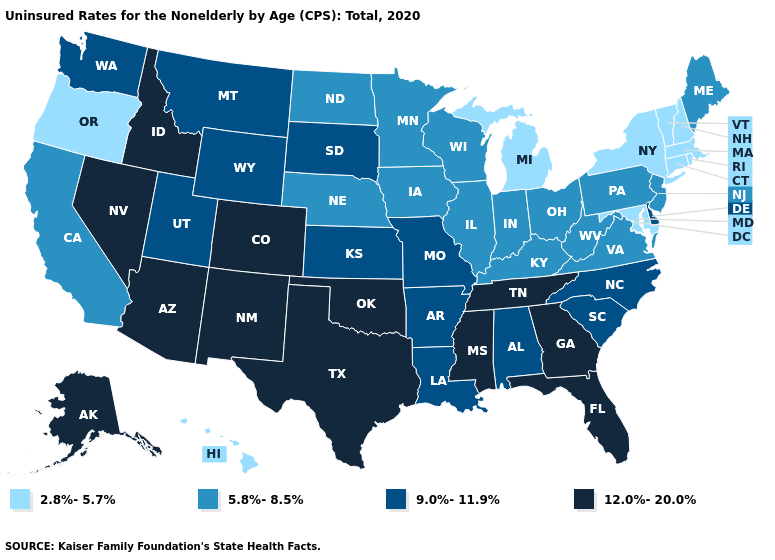Name the states that have a value in the range 2.8%-5.7%?
Concise answer only. Connecticut, Hawaii, Maryland, Massachusetts, Michigan, New Hampshire, New York, Oregon, Rhode Island, Vermont. What is the value of Rhode Island?
Be succinct. 2.8%-5.7%. Among the states that border Illinois , which have the highest value?
Be succinct. Missouri. Does Delaware have a higher value than New Mexico?
Write a very short answer. No. Does the map have missing data?
Keep it brief. No. What is the highest value in the USA?
Short answer required. 12.0%-20.0%. Name the states that have a value in the range 9.0%-11.9%?
Quick response, please. Alabama, Arkansas, Delaware, Kansas, Louisiana, Missouri, Montana, North Carolina, South Carolina, South Dakota, Utah, Washington, Wyoming. Does New Mexico have the highest value in the USA?
Give a very brief answer. Yes. Among the states that border California , does Oregon have the highest value?
Short answer required. No. Among the states that border Tennessee , which have the lowest value?
Answer briefly. Kentucky, Virginia. What is the lowest value in states that border Maryland?
Quick response, please. 5.8%-8.5%. What is the value of Illinois?
Answer briefly. 5.8%-8.5%. What is the value of Georgia?
Short answer required. 12.0%-20.0%. Which states have the lowest value in the West?
Write a very short answer. Hawaii, Oregon. Which states have the highest value in the USA?
Keep it brief. Alaska, Arizona, Colorado, Florida, Georgia, Idaho, Mississippi, Nevada, New Mexico, Oklahoma, Tennessee, Texas. 